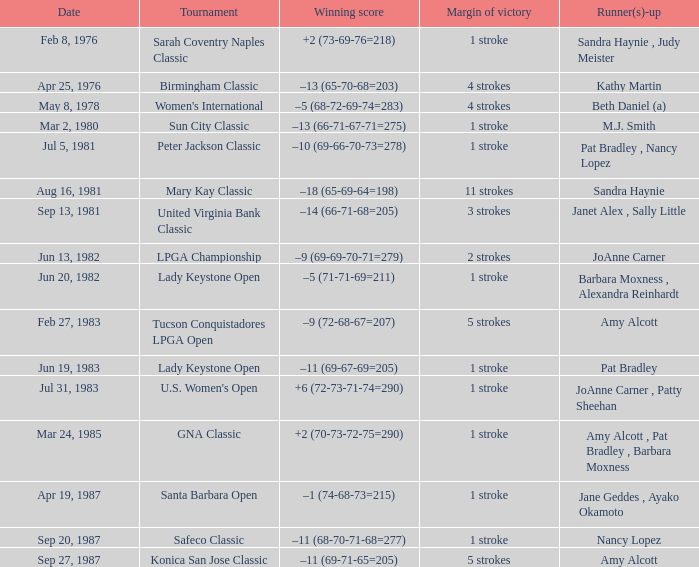I'm looking to parse the entire table for insights. Could you assist me with that? {'header': ['Date', 'Tournament', 'Winning score', 'Margin of victory', 'Runner(s)-up'], 'rows': [['Feb 8, 1976', 'Sarah Coventry Naples Classic', '+2 (73-69-76=218)', '1 stroke', 'Sandra Haynie , Judy Meister'], ['Apr 25, 1976', 'Birmingham Classic', '–13 (65-70-68=203)', '4 strokes', 'Kathy Martin'], ['May 8, 1978', "Women's International", '–5 (68-72-69-74=283)', '4 strokes', 'Beth Daniel (a)'], ['Mar 2, 1980', 'Sun City Classic', '–13 (66-71-67-71=275)', '1 stroke', 'M.J. Smith'], ['Jul 5, 1981', 'Peter Jackson Classic', '–10 (69-66-70-73=278)', '1 stroke', 'Pat Bradley , Nancy Lopez'], ['Aug 16, 1981', 'Mary Kay Classic', '–18 (65-69-64=198)', '11 strokes', 'Sandra Haynie'], ['Sep 13, 1981', 'United Virginia Bank Classic', '–14 (66-71-68=205)', '3 strokes', 'Janet Alex , Sally Little'], ['Jun 13, 1982', 'LPGA Championship', '–9 (69-69-70-71=279)', '2 strokes', 'JoAnne Carner'], ['Jun 20, 1982', 'Lady Keystone Open', '–5 (71-71-69=211)', '1 stroke', 'Barbara Moxness , Alexandra Reinhardt'], ['Feb 27, 1983', 'Tucson Conquistadores LPGA Open', '–9 (72-68-67=207)', '5 strokes', 'Amy Alcott'], ['Jun 19, 1983', 'Lady Keystone Open', '–11 (69-67-69=205)', '1 stroke', 'Pat Bradley'], ['Jul 31, 1983', "U.S. Women's Open", '+6 (72-73-71-74=290)', '1 stroke', 'JoAnne Carner , Patty Sheehan'], ['Mar 24, 1985', 'GNA Classic', '+2 (70-73-72-75=290)', '1 stroke', 'Amy Alcott , Pat Bradley , Barbara Moxness'], ['Apr 19, 1987', 'Santa Barbara Open', '–1 (74-68-73=215)', '1 stroke', 'Jane Geddes , Ayako Okamoto'], ['Sep 20, 1987', 'Safeco Classic', '–11 (68-70-71-68=277)', '1 stroke', 'Nancy Lopez'], ['Sep 27, 1987', 'Konica San Jose Classic', '–11 (69-71-65=205)', '5 strokes', 'Amy Alcott']]} What is the triumphing score during the tournament at safeco classic? –11 (68-70-71-68=277). 